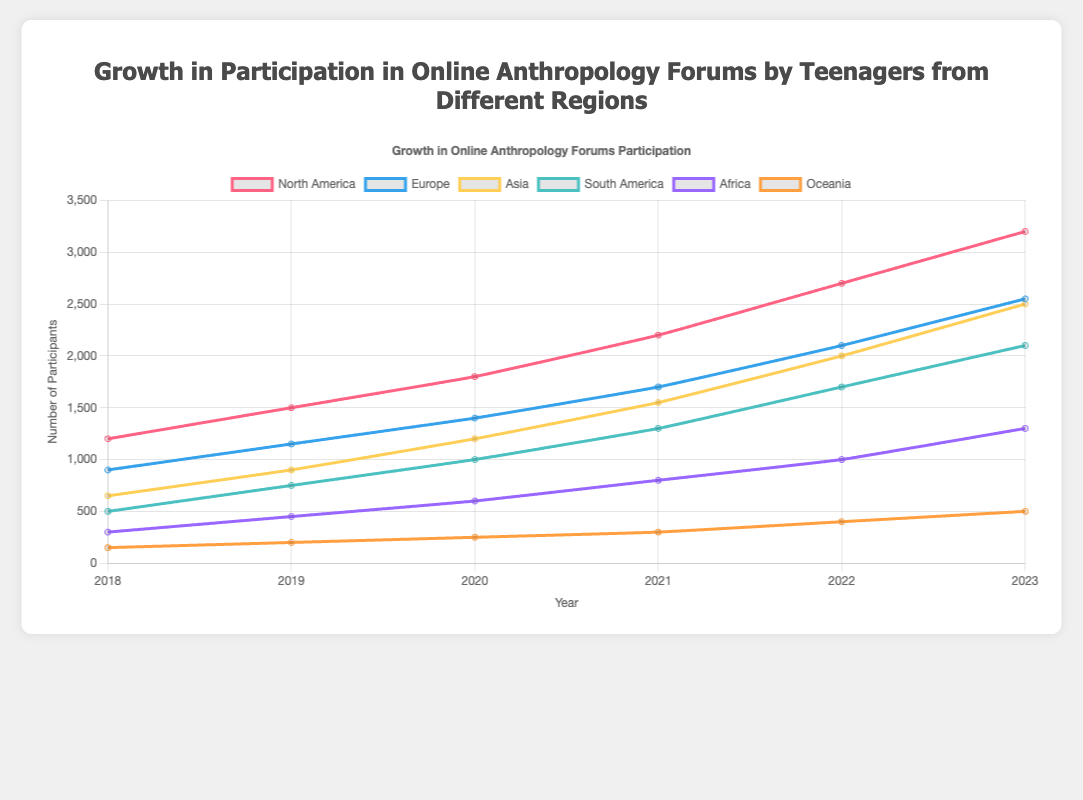Which region had the highest participation in online anthropology forums in 2023? To find which region had the highest participation in 2023, look for the highest point on the line representing 2023 values. North America has the highest value in 2023 with 3200 participants.
Answer: North America What was the total number of participants across all regions in 2020? Add up the participant numbers for all regions in 2020: North America (1800) + Europe (1400) + Asia (1200) + South America (1000) + Africa (600) + Oceania (250). The total is 1800 + 1400 + 1200 + 1000 + 600 + 250 = 6250.
Answer: 6250 Did the participation in Oceania grow steadily each year from 2018 to 2023? Check each year’s participant number for Oceania from 2018 (150), 2019 (200), 2020 (250), 2021 (300), 2022 (400), and 2023 (500). Each year’s value is greater than the previous year, indicating steady growth.
Answer: Yes What is the average number of participants in Europe from 2018 to 2023? Add the participant numbers for Europe from each year: 900 (2018) + 1150 (2019) + 1400 (2020) + 1700 (2021) + 2100 (2022) + 2550 (2023). The total is 9800. Divide by the 6 years: 9800 / 6 = 1633.33.
Answer: 1633.33 Which region saw the largest increase in participation from 2018 to 2023, and what was the amount of this increase? Calculate the change for each region from 2018 to 2023, and find the largest: North America (3200 - 1200 = 2000), Europe (2550 - 900 = 1650), Asia (2500 - 650 = 1850), South America (2100 - 500 = 1600), Africa (1300 - 300 = 1000), Oceania (500 - 150 = 350). North America saw the largest increase of 2000 participants.
Answer: North America, 2000 Which region had the least growth from 2019 to 2020, and what was the amount of this growth? Calculate the growth from 2019 to 2020 for each region, and find the smallest: North America (1800 - 1500 = 300), Europe (1400 - 1150 = 250), Asia (1200 - 900 = 300), South America (1000 - 750 = 250), Africa (600 - 450 = 150), Oceania (250 - 200 = 50). Oceania had the least growth with 50 participants.
Answer: Oceania, 50 In what year did Africa first reach over 1000 participants? Look at the data for Africa and find the first year with participants over 1000. In 2022, Africa reached 1000 participants.
Answer: 2022 Compare the number of participants in 2018 and 2023 for Asia. What is the percentage increase? Calculate the increase: 2500 (2023) - 650 (2018) = 1850. Then, find the percentage: (1850 / 650) * 100 = ~284.62%.
Answer: ~284.62% What was the second highest number of participants in 2023? Examine the values for 2023 across all regions. The highest is North America (3200), and the second highest is Europe (2550).
Answer: Europe, 2550 